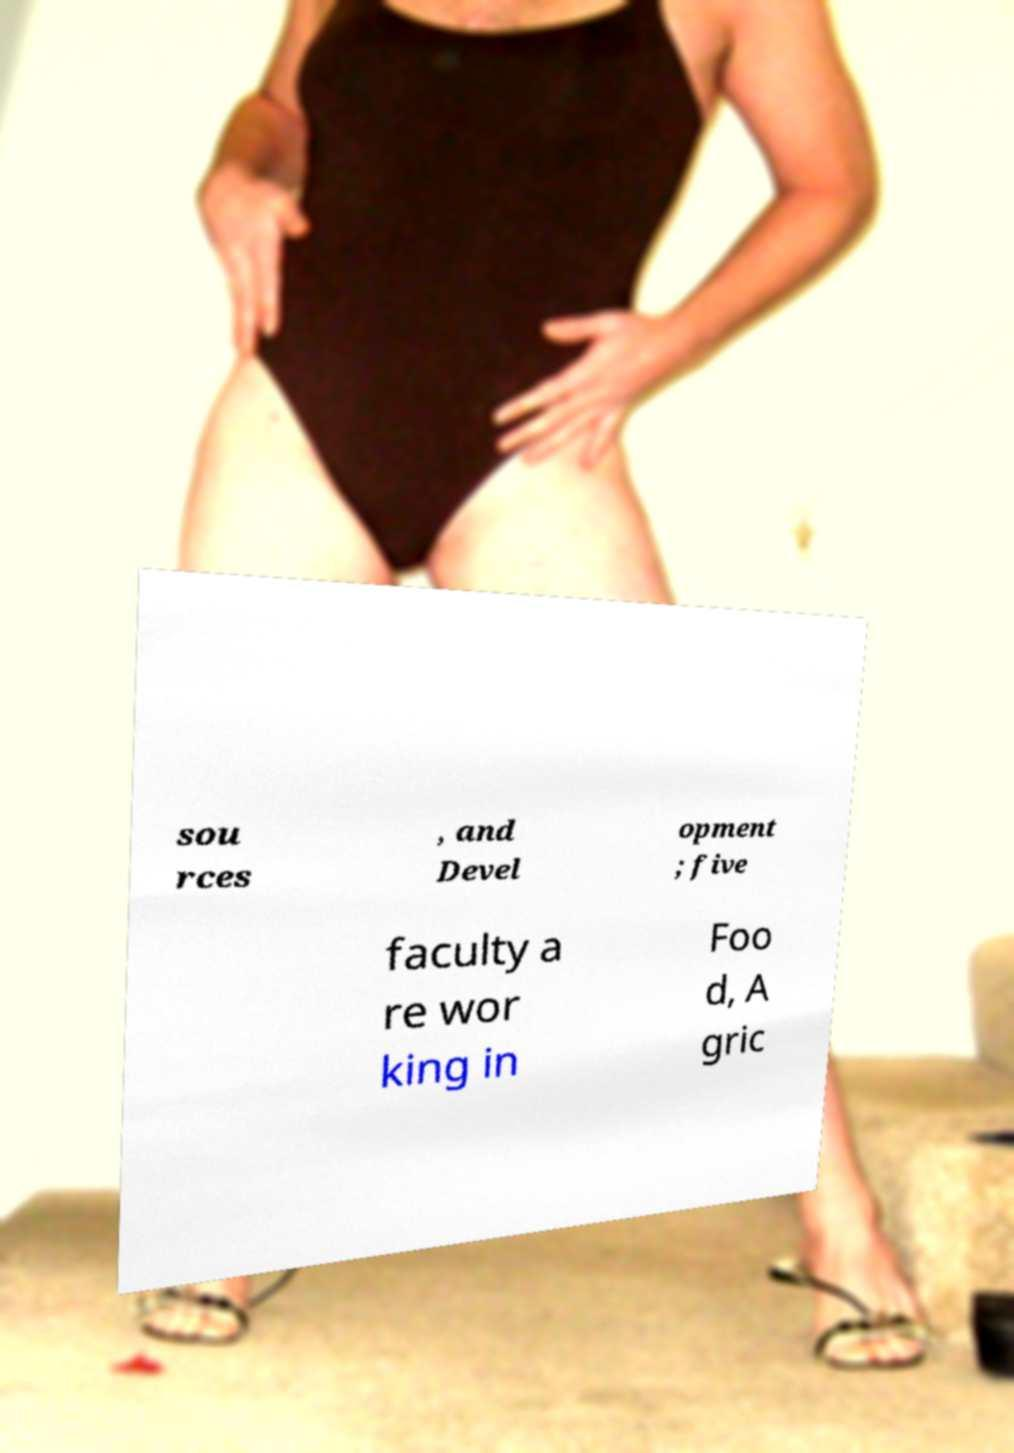I need the written content from this picture converted into text. Can you do that? sou rces , and Devel opment ; five faculty a re wor king in Foo d, A gric 